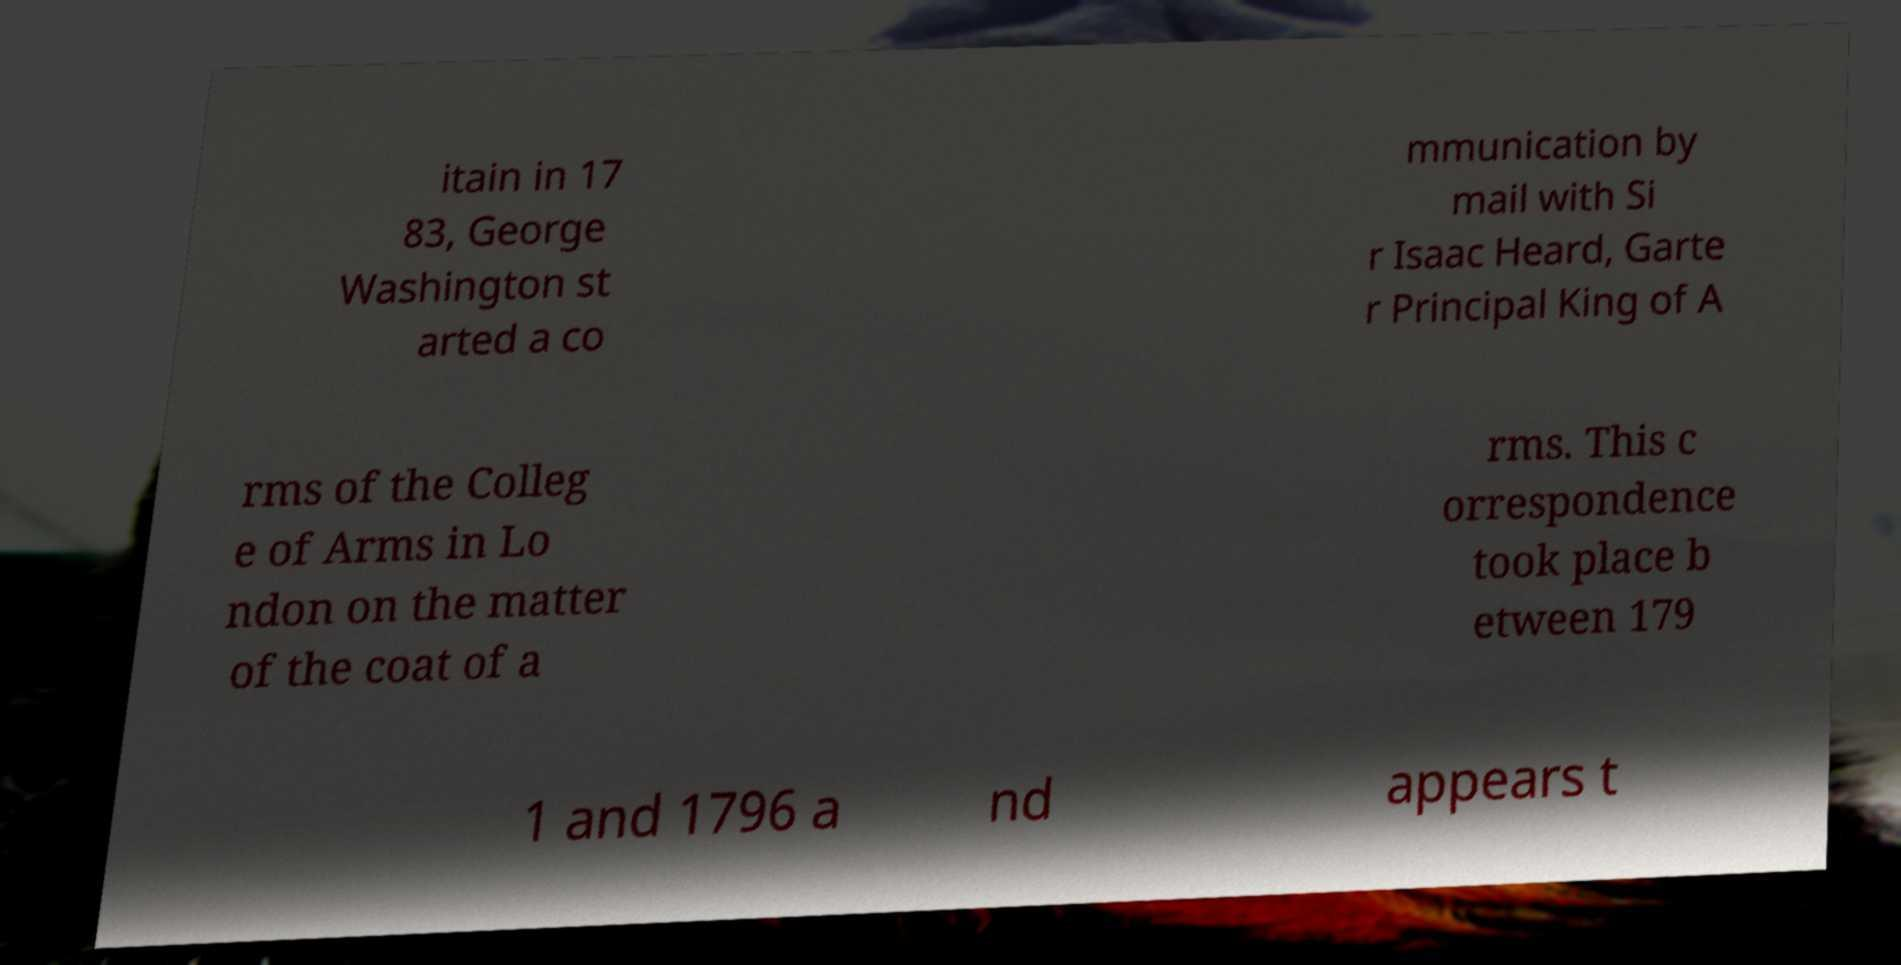What messages or text are displayed in this image? I need them in a readable, typed format. itain in 17 83, George Washington st arted a co mmunication by mail with Si r Isaac Heard, Garte r Principal King of A rms of the Colleg e of Arms in Lo ndon on the matter of the coat of a rms. This c orrespondence took place b etween 179 1 and 1796 a nd appears t 